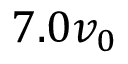Convert formula to latex. <formula><loc_0><loc_0><loc_500><loc_500>7 . 0 v _ { 0 }</formula> 